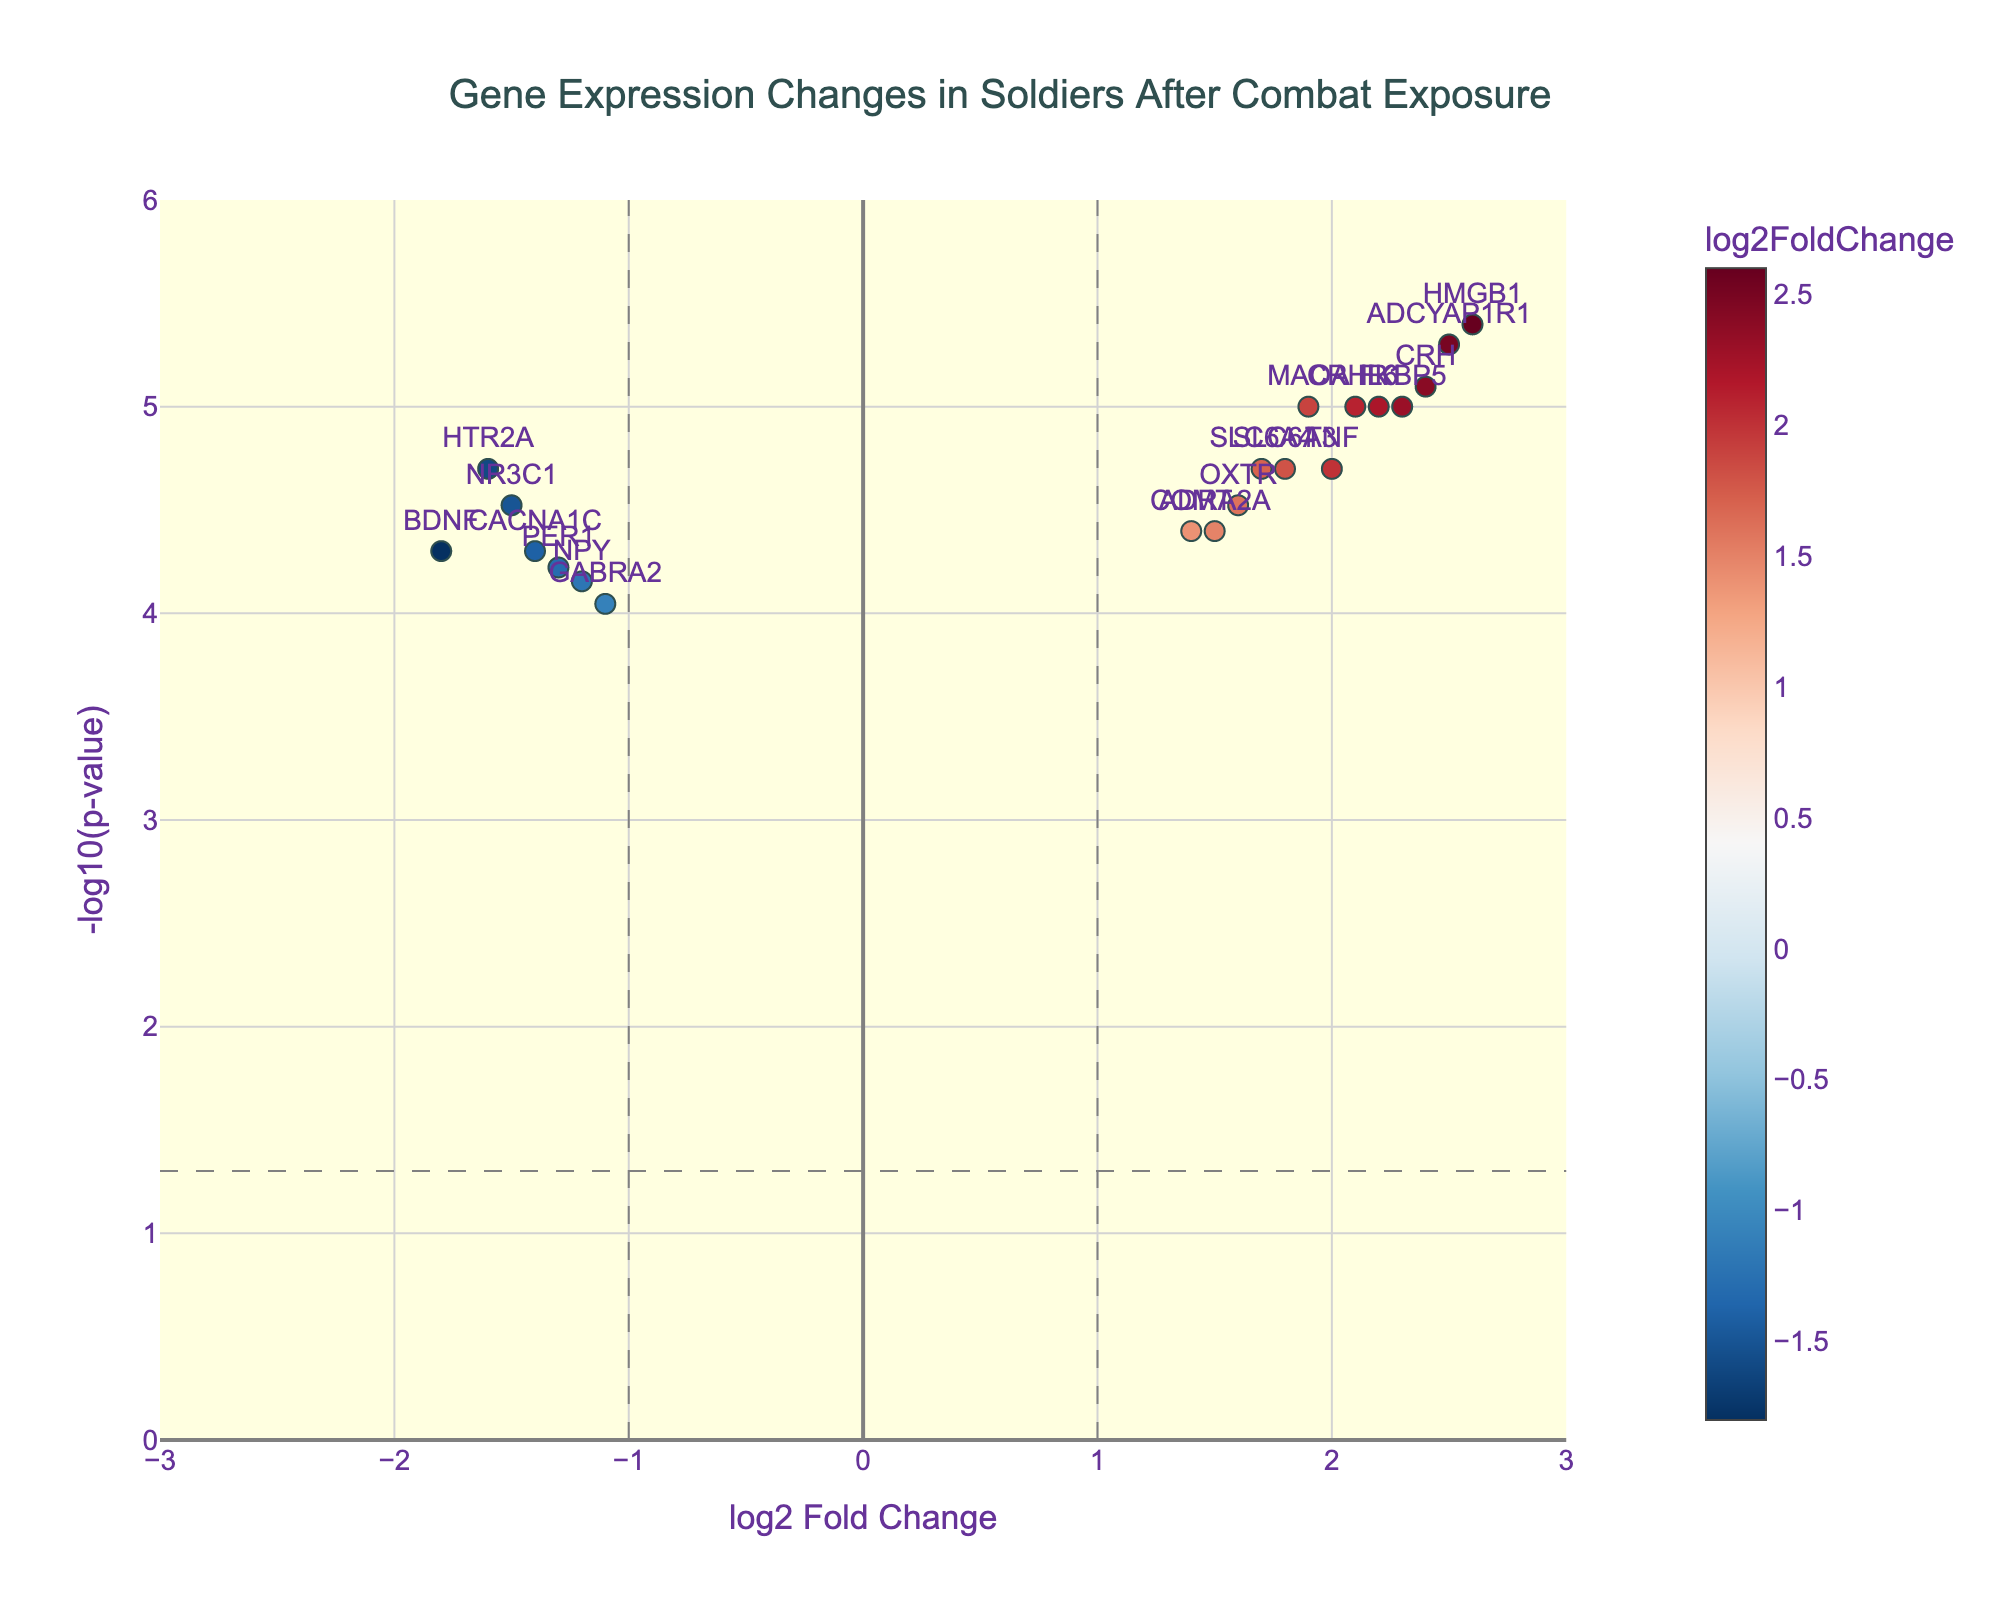How many genes show a significant change in gene expression after combat exposure? To find the number of genes with significant changes, look for points above the horizontal line representing the significance threshold. There are 20 such points.
Answer: 20 Which gene has the highest increase in expression after combat exposure? To identify the gene with the highest increase, look for the highest point with a positive log2FoldChange value. That gene is HMGB1.
Answer: HMGB1 Which gene has the most significant p-value? The most significant p-value corresponds to the highest -log10(p-value) on the y-axis. The gene ADCYAP1R1 has the highest -log10(pvalue).
Answer: ADCYAP1R1 Which genes show a decrease in expression after combat exposure? Genes with a decrease in expression will have a negative log2FoldChange. The genes falling on the left side of the vertical line at zero are NR3C1, BDNF, NPY, HTR2A, PER1, and GABRA2.
Answer: NR3C1, BDNF, NPY, HTR2A, PER1, GABRA2 How many genes have a log2FoldChange greater than 2? Count the number of points with a log2FoldChange value greater than 2. These genes are FKBP5, CRHR1, IL6, CRH, ADCYAP1R1, and HMGB1.
Answer: 6 What is the log2FoldChange and p-value for the CRH gene? For the CRH gene, find its coordinates on the plot. The log2FoldChange is 2.4 and the p-value is 0.000008, confirmed by the hover text.
Answer: 2.4, 0.000008 Which genes show upregulated expression above a -log10(p-value) of 5? To find these genes, look for upregulated genes (positive log2FoldChange) above the horizontal line at -log10(p-value) = 5. The genes are HMGB1 and ADCYAP1R1.
Answer: HMGB1, ADCYAP1R1 What can you infer about the stress-related gene CRH from the plot? CRH has a significant increase in expression with a log2FoldChange of 2.4 and a significant p-value indicated by being positioned high on the y-axis. This suggests it may play a role in the stress response to combat.
Answer: Significant increase, possible stress response role 